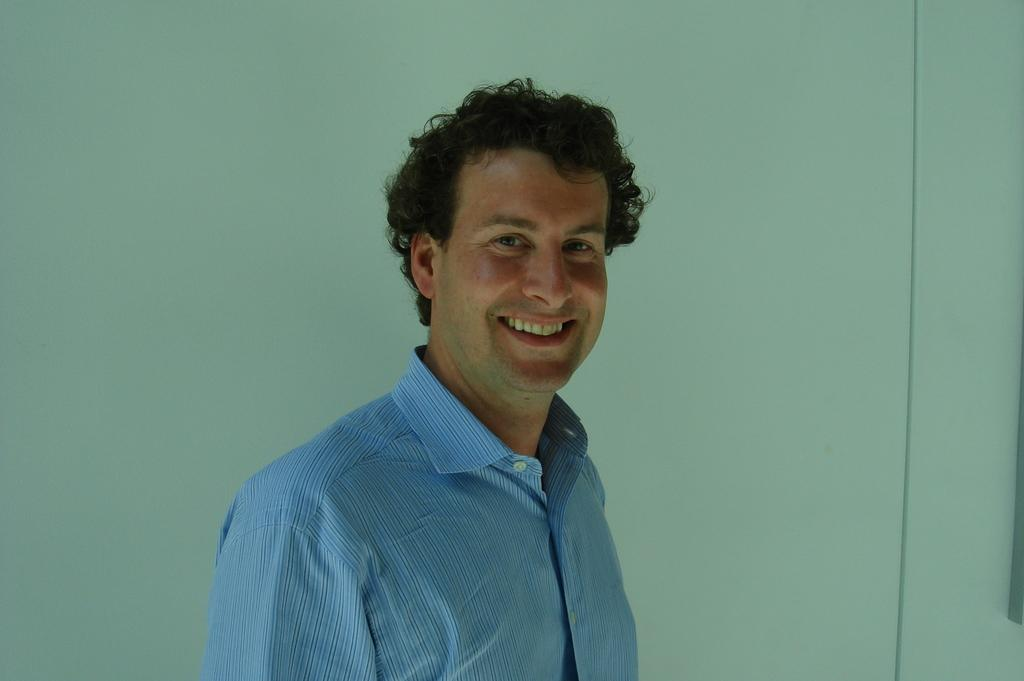Who or what is in the image? There is a person in the image. What is the person doing in the image? The person is standing in the image. How does the person appear to be feeling in the image? The person has a smile on their face, indicating a positive or happy emotion. What is visible behind the person in the image? There is a wall behind the person in the image. How many baby cattle can be seen in the image? There are no baby cattle present in the image; it features a person standing with a smile and a wall in the background. 